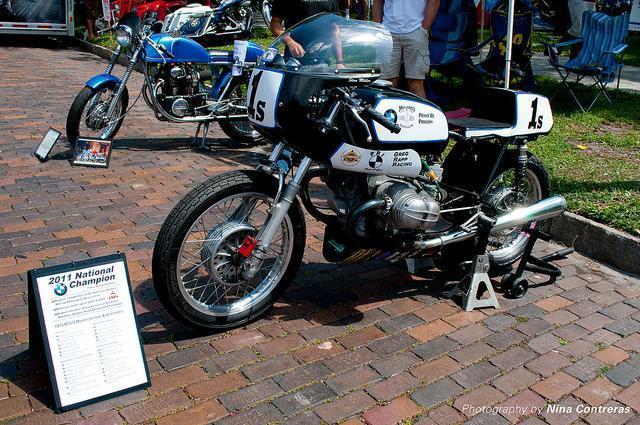How many motorcycles are visible?
Give a very brief answer. 2. How many cows inside the fence?
Give a very brief answer. 0. 